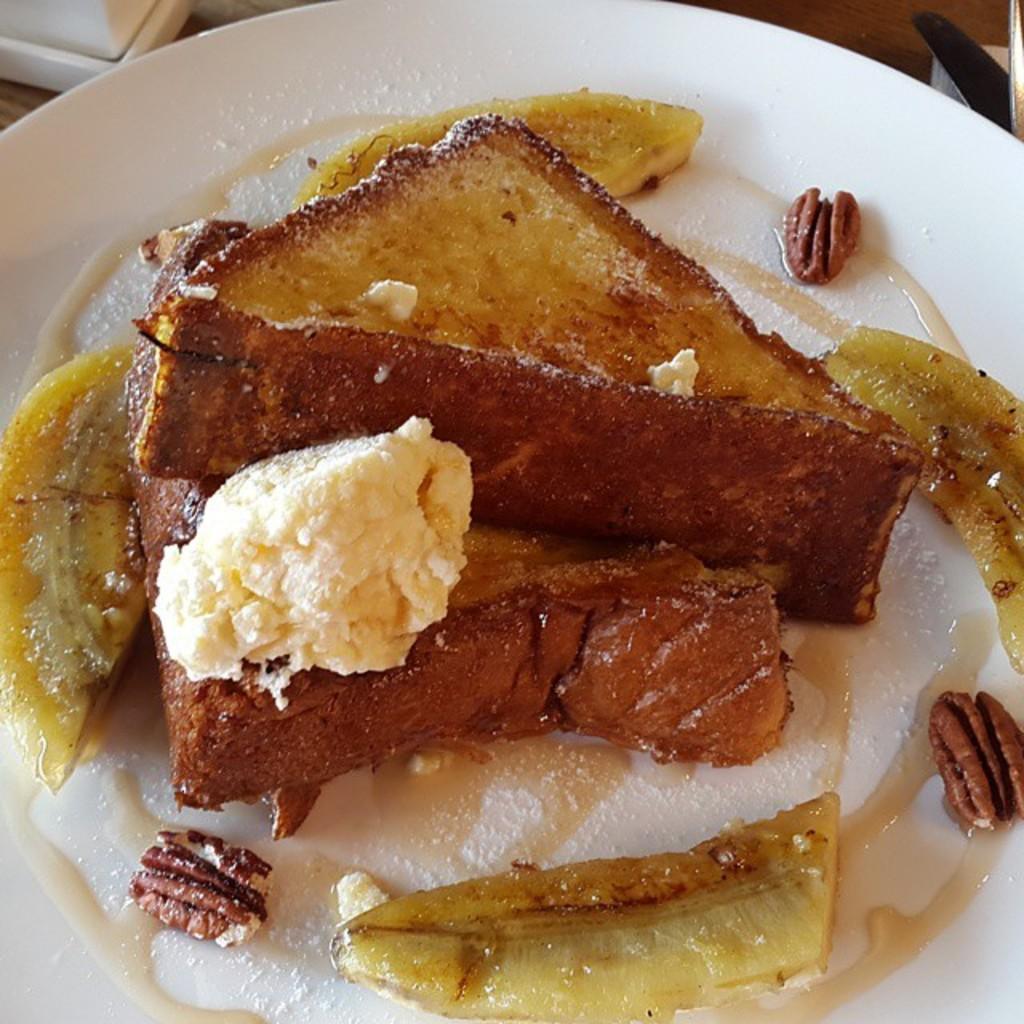In one or two sentences, can you explain what this image depicts? In this image we can see a plate with some food on the wooden surface, which looks like a table. 